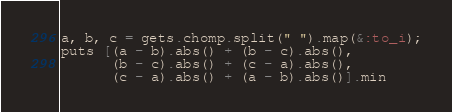<code> <loc_0><loc_0><loc_500><loc_500><_Ruby_>a, b, c = gets.chomp.split(" ").map(&:to_i);
puts [(a - b).abs() + (b - c).abs(),
      (b - c).abs() + (c - a).abs(),
      (c - a).abs() + (a - b).abs()].min
</code> 